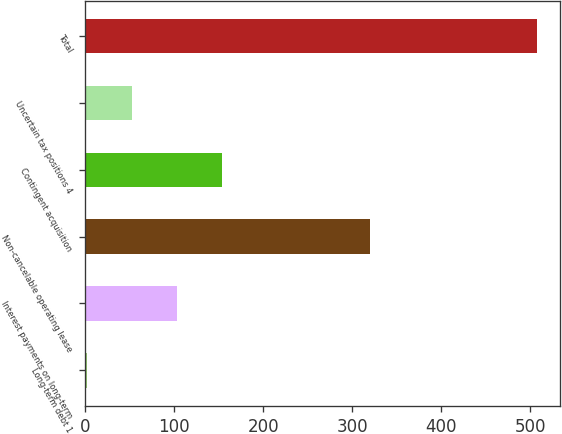Convert chart to OTSL. <chart><loc_0><loc_0><loc_500><loc_500><bar_chart><fcel>Long-term debt 1<fcel>Interest payments on long-term<fcel>Non-cancelable operating lease<fcel>Contingent acquisition<fcel>Uncertain tax positions 4<fcel>Total<nl><fcel>2.1<fcel>103.14<fcel>320<fcel>153.66<fcel>52.62<fcel>507.3<nl></chart> 